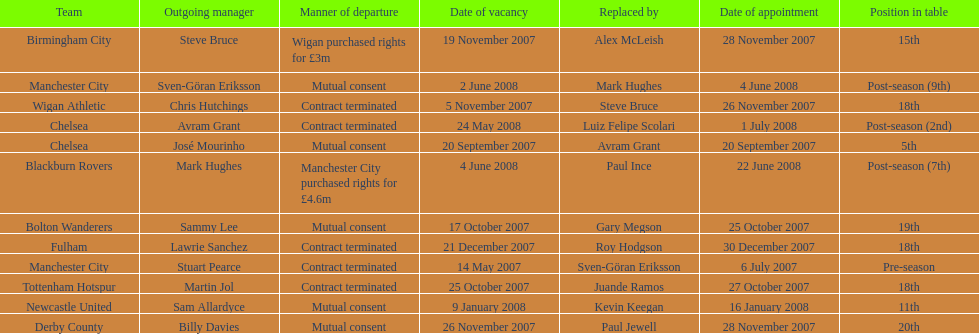What was the top team according to position in table called? Manchester City. 